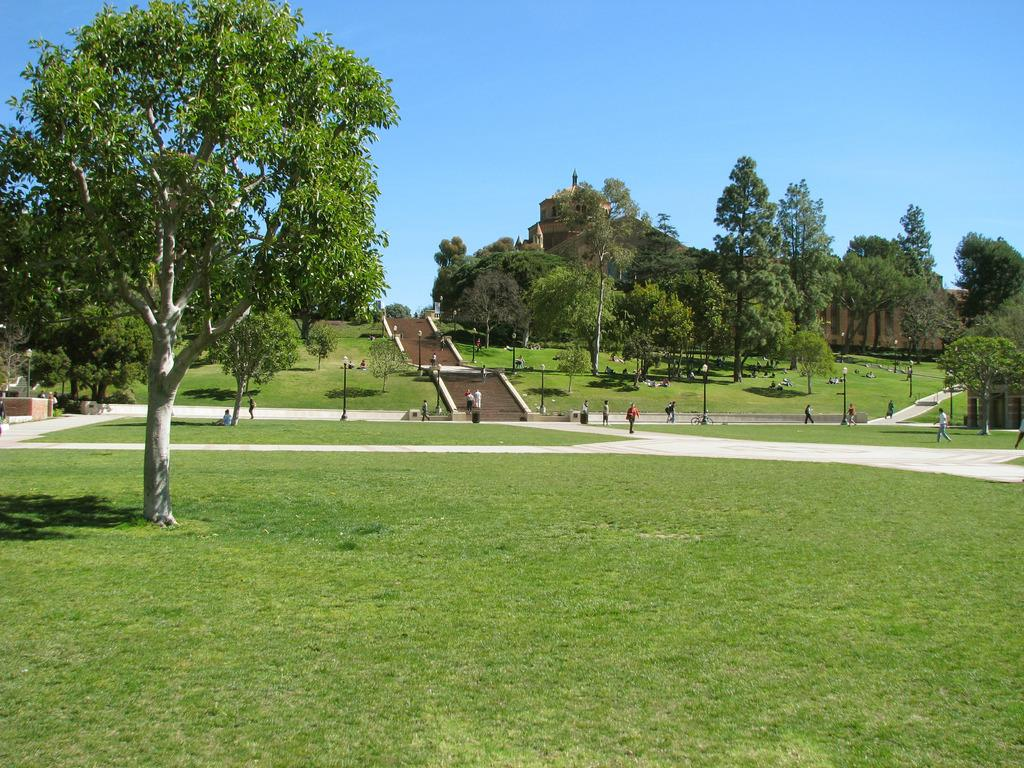What type of vegetation can be seen in the image? There are trees in the image. Who or what else is present in the image? There are people in the image. What architectural feature is located in the center of the image? There are stairs in the center of the image. What type of ground surface is visible at the bottom of the image? There is grass at the bottom of the image. What can be seen in the background of the image? The sky is visible in the background of the image. Who is the owner of the smoke seen in the image? There is no smoke present in the image, so it is not possible to determine an owner. 